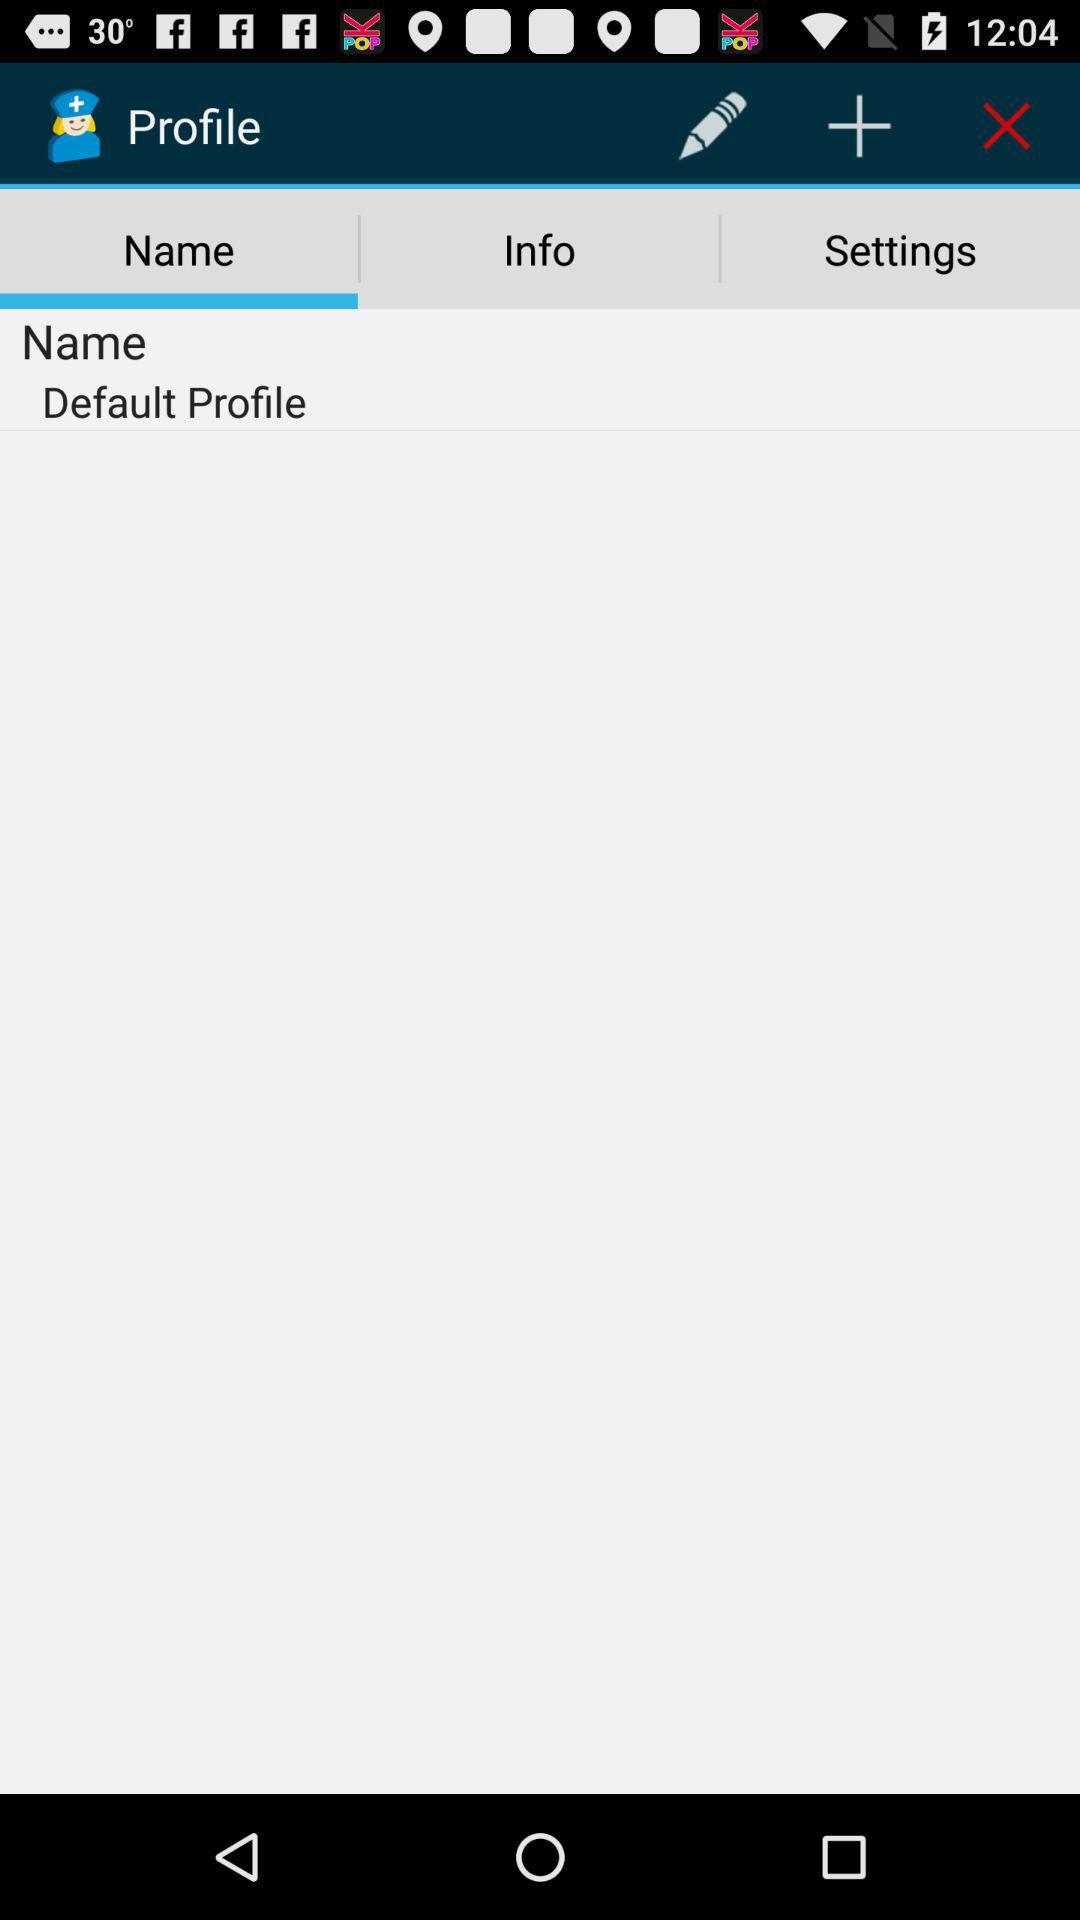Which tab is selected? The selected tab is "Name". 